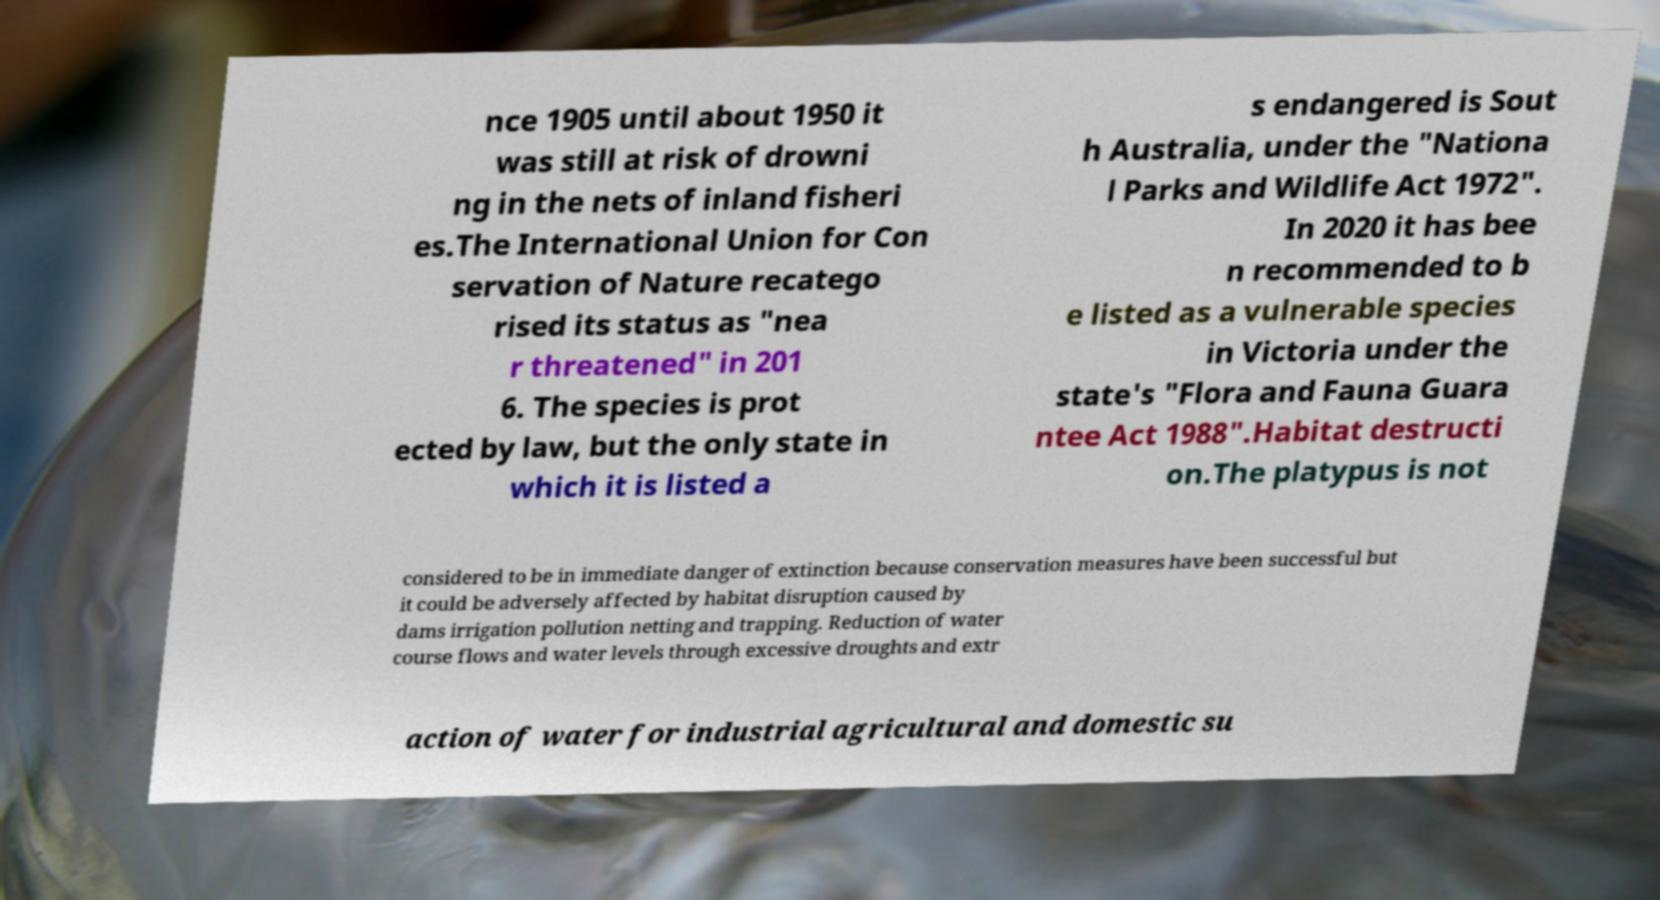What messages or text are displayed in this image? I need them in a readable, typed format. nce 1905 until about 1950 it was still at risk of drowni ng in the nets of inland fisheri es.The International Union for Con servation of Nature recatego rised its status as "nea r threatened" in 201 6. The species is prot ected by law, but the only state in which it is listed a s endangered is Sout h Australia, under the "Nationa l Parks and Wildlife Act 1972". In 2020 it has bee n recommended to b e listed as a vulnerable species in Victoria under the state's "Flora and Fauna Guara ntee Act 1988".Habitat destructi on.The platypus is not considered to be in immediate danger of extinction because conservation measures have been successful but it could be adversely affected by habitat disruption caused by dams irrigation pollution netting and trapping. Reduction of water course flows and water levels through excessive droughts and extr action of water for industrial agricultural and domestic su 